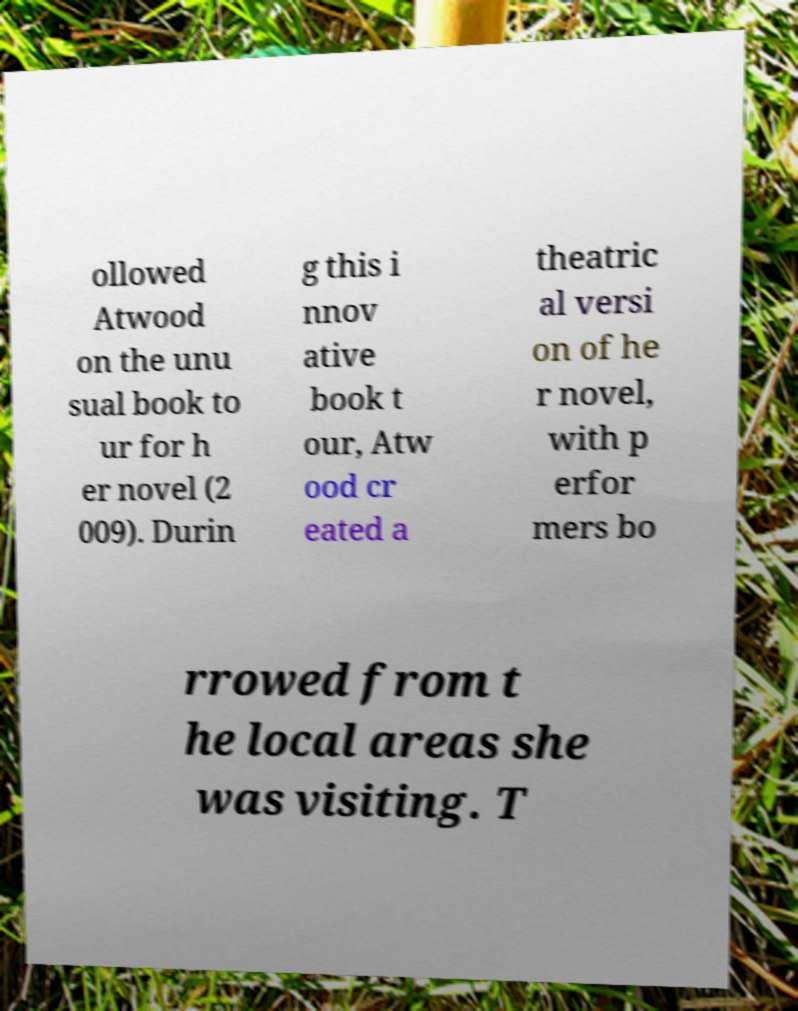Please identify and transcribe the text found in this image. ollowed Atwood on the unu sual book to ur for h er novel (2 009). Durin g this i nnov ative book t our, Atw ood cr eated a theatric al versi on of he r novel, with p erfor mers bo rrowed from t he local areas she was visiting. T 